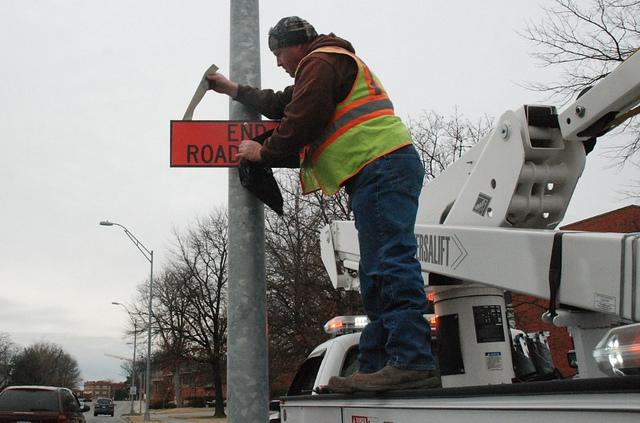Is he fixing a signal?
Answer briefly. Yes. What is he touching?
Quick response, please. Sign. What is the man standing on?
Give a very brief answer. Truck. What is the man doing?
Answer briefly. Fixing sign. What does the T-Shirt of the man not skateboarding say?
Write a very short answer. Nothing. How many people in the picture?
Write a very short answer. 1. Is the man wearing normal skateboard attire?
Concise answer only. No. 